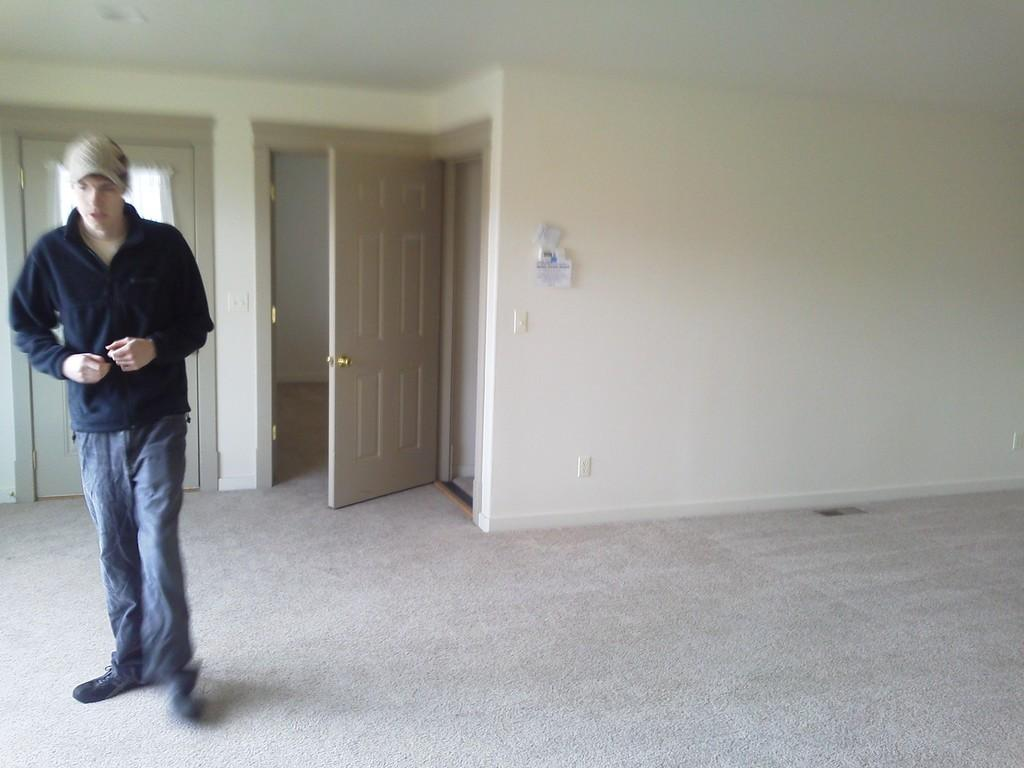What is the position of the man in the image? The man is standing on the left side of the image. What is on the floor in the image? There is a carpet on the floor in the image. What can be seen in the background of the image? There are doors in the backdrop of the image. What is on the right side of the image? There is a wall on the right side of the image. What type of patch is being discussed by the committee in the image? There is no committee or patch present in the image. What is being served for lunch in the image? There is no lunch or indication of food in the image. 